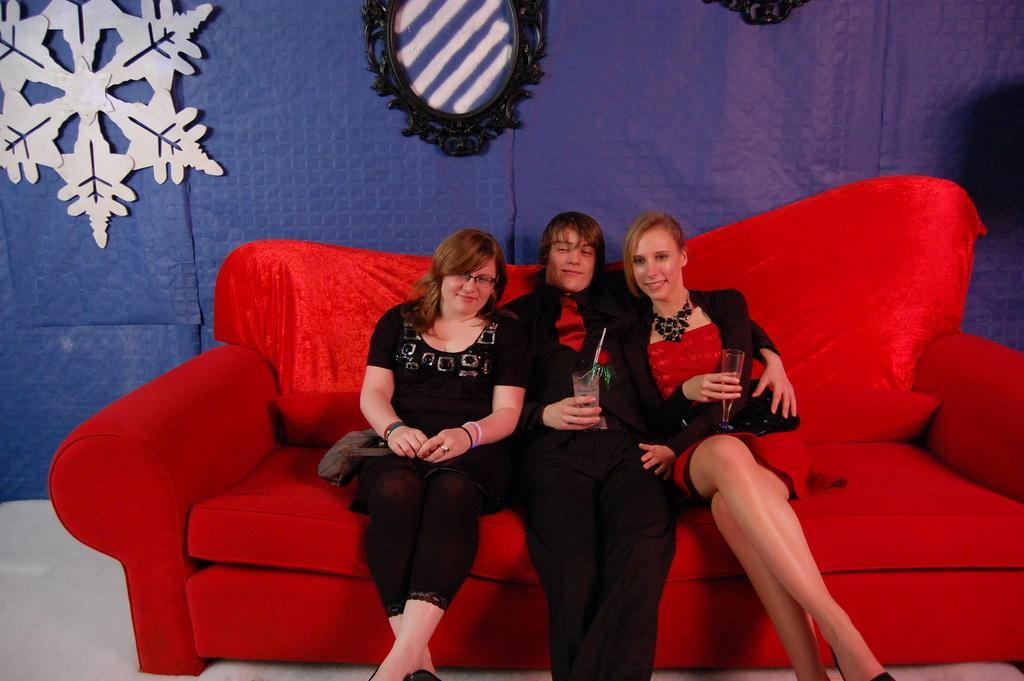How would you summarize this image in a sentence or two? Here there are two girls sitting on either side of a man. He is holding a glass. It's a red color sofa behind them there is a mirror. 